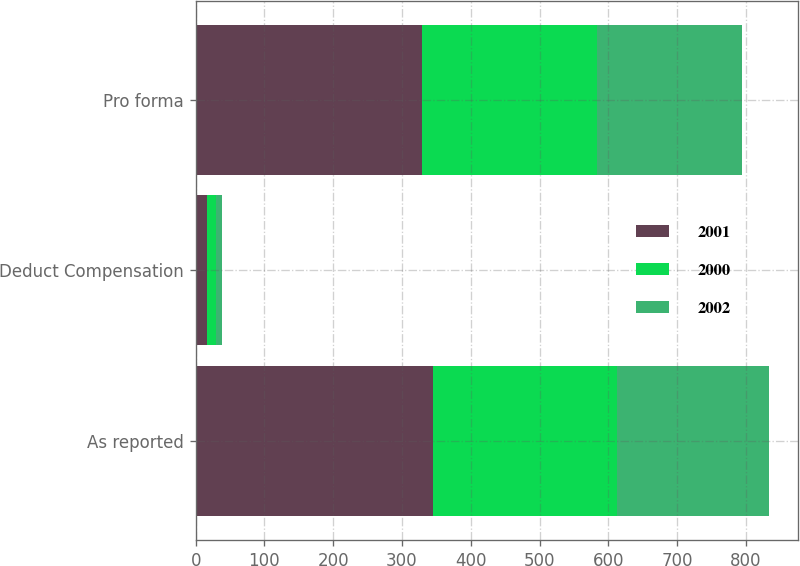Convert chart to OTSL. <chart><loc_0><loc_0><loc_500><loc_500><stacked_bar_chart><ecel><fcel>As reported<fcel>Deduct Compensation<fcel>Pro forma<nl><fcel>2001<fcel>345.6<fcel>17.1<fcel>328.5<nl><fcel>2000<fcel>267<fcel>11.8<fcel>255.2<nl><fcel>2002<fcel>221<fcel>9.9<fcel>211.1<nl></chart> 